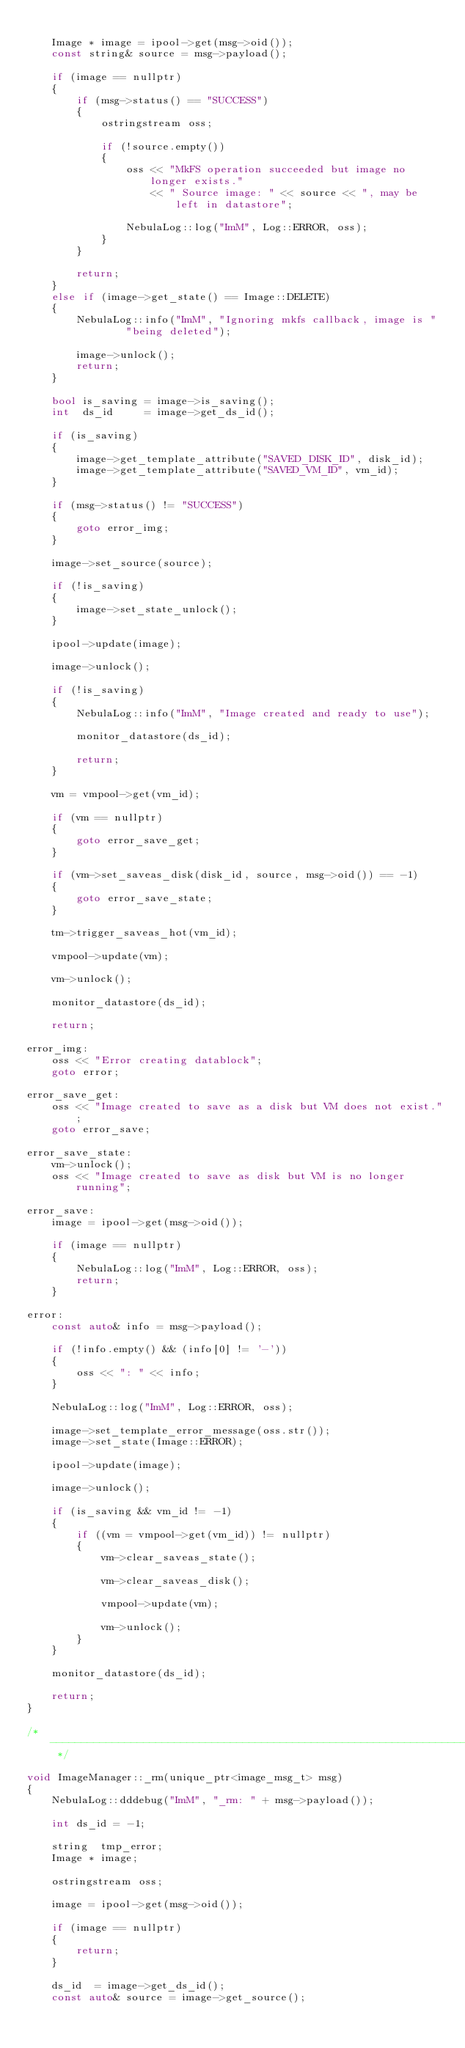Convert code to text. <code><loc_0><loc_0><loc_500><loc_500><_C++_>
    Image * image = ipool->get(msg->oid());
    const string& source = msg->payload();

    if (image == nullptr)
    {
        if (msg->status() == "SUCCESS")
        {
            ostringstream oss;

            if (!source.empty())
            {
                oss << "MkFS operation succeeded but image no longer exists."
                    << " Source image: " << source << ", may be left in datastore";

                NebulaLog::log("ImM", Log::ERROR, oss);
            }
        }

        return;
    }
    else if (image->get_state() == Image::DELETE)
    {
        NebulaLog::info("ImM", "Ignoring mkfs callback, image is "
                "being deleted");

        image->unlock();
        return;
    }

    bool is_saving = image->is_saving();
    int  ds_id     = image->get_ds_id();

    if (is_saving)
    {
        image->get_template_attribute("SAVED_DISK_ID", disk_id);
        image->get_template_attribute("SAVED_VM_ID", vm_id);
    }

    if (msg->status() != "SUCCESS")
    {
        goto error_img;
    }

    image->set_source(source);

    if (!is_saving)
    {
        image->set_state_unlock();
    }

    ipool->update(image);

    image->unlock();

    if (!is_saving)
    {
        NebulaLog::info("ImM", "Image created and ready to use");

        monitor_datastore(ds_id);

        return;
    }

    vm = vmpool->get(vm_id);

    if (vm == nullptr)
    {
        goto error_save_get;
    }

    if (vm->set_saveas_disk(disk_id, source, msg->oid()) == -1)
    {
        goto error_save_state;
    }

    tm->trigger_saveas_hot(vm_id);

    vmpool->update(vm);

    vm->unlock();

    monitor_datastore(ds_id);

    return;

error_img:
    oss << "Error creating datablock";
    goto error;

error_save_get:
    oss << "Image created to save as a disk but VM does not exist.";
    goto error_save;

error_save_state:
    vm->unlock();
    oss << "Image created to save as disk but VM is no longer running";

error_save:
    image = ipool->get(msg->oid());

    if (image == nullptr)
    {
        NebulaLog::log("ImM", Log::ERROR, oss);
        return;
    }

error:
    const auto& info = msg->payload();

    if (!info.empty() && (info[0] != '-'))
    {
        oss << ": " << info;
    }

    NebulaLog::log("ImM", Log::ERROR, oss);

    image->set_template_error_message(oss.str());
    image->set_state(Image::ERROR);

    ipool->update(image);

    image->unlock();

    if (is_saving && vm_id != -1)
    {
        if ((vm = vmpool->get(vm_id)) != nullptr)
        {
            vm->clear_saveas_state();

            vm->clear_saveas_disk();

            vmpool->update(vm);

            vm->unlock();
        }
    }

    monitor_datastore(ds_id);

    return;
}

/* -------------------------------------------------------------------------- */

void ImageManager::_rm(unique_ptr<image_msg_t> msg)
{
    NebulaLog::dddebug("ImM", "_rm: " + msg->payload());

    int ds_id = -1;

    string  tmp_error;
    Image * image;

    ostringstream oss;

    image = ipool->get(msg->oid());

    if (image == nullptr)
    {
        return;
    }

    ds_id  = image->get_ds_id();
    const auto& source = image->get_source();
</code> 